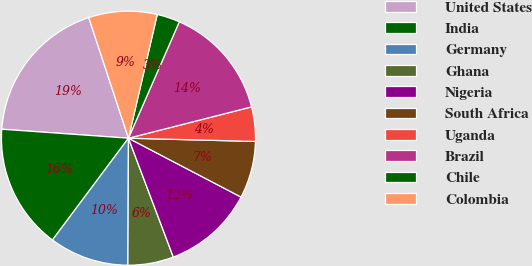Convert chart. <chart><loc_0><loc_0><loc_500><loc_500><pie_chart><fcel>United States<fcel>India<fcel>Germany<fcel>Ghana<fcel>Nigeria<fcel>South Africa<fcel>Uganda<fcel>Brazil<fcel>Chile<fcel>Colombia<nl><fcel>18.81%<fcel>15.92%<fcel>10.14%<fcel>5.81%<fcel>11.59%<fcel>7.26%<fcel>4.37%<fcel>14.48%<fcel>2.92%<fcel>8.7%<nl></chart> 